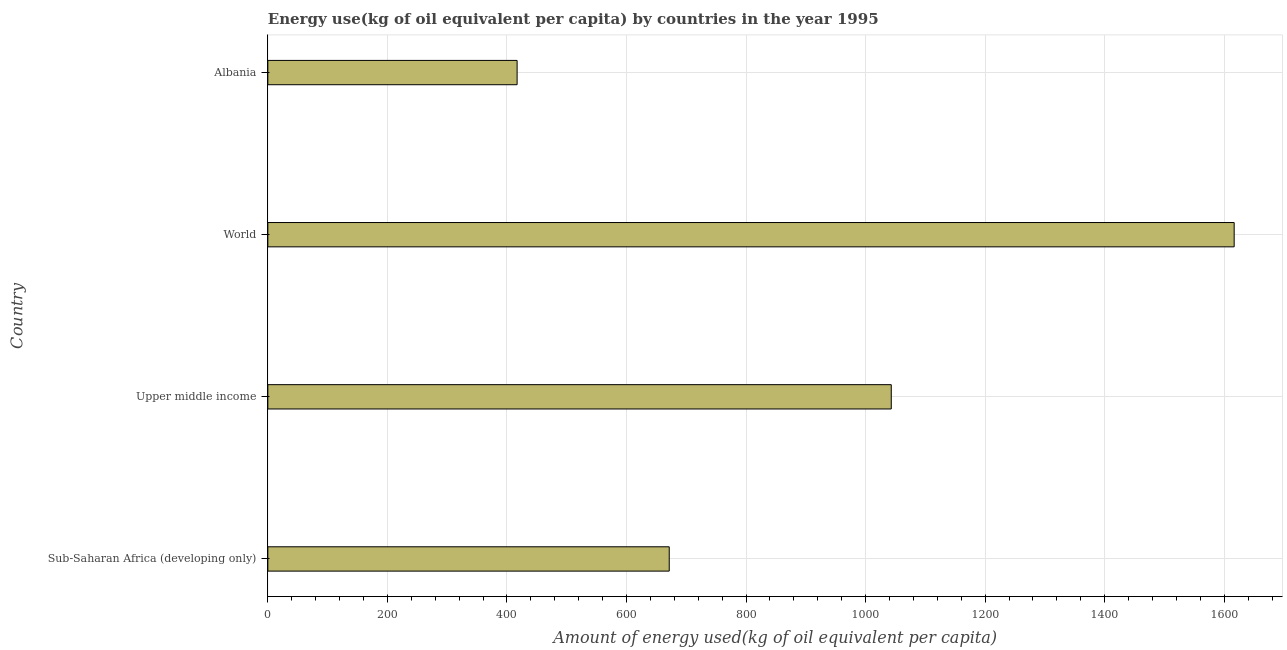What is the title of the graph?
Your answer should be compact. Energy use(kg of oil equivalent per capita) by countries in the year 1995. What is the label or title of the X-axis?
Make the answer very short. Amount of energy used(kg of oil equivalent per capita). What is the amount of energy used in Albania?
Make the answer very short. 417.03. Across all countries, what is the maximum amount of energy used?
Offer a very short reply. 1616.71. Across all countries, what is the minimum amount of energy used?
Keep it short and to the point. 417.03. In which country was the amount of energy used maximum?
Give a very brief answer. World. In which country was the amount of energy used minimum?
Keep it short and to the point. Albania. What is the sum of the amount of energy used?
Make the answer very short. 3748.29. What is the difference between the amount of energy used in Sub-Saharan Africa (developing only) and Upper middle income?
Your answer should be compact. -371.49. What is the average amount of energy used per country?
Ensure brevity in your answer.  937.07. What is the median amount of energy used?
Your answer should be very brief. 857.28. What is the ratio of the amount of energy used in Albania to that in World?
Your response must be concise. 0.26. Is the amount of energy used in Sub-Saharan Africa (developing only) less than that in Upper middle income?
Your response must be concise. Yes. Is the difference between the amount of energy used in Albania and World greater than the difference between any two countries?
Ensure brevity in your answer.  Yes. What is the difference between the highest and the second highest amount of energy used?
Give a very brief answer. 573.69. What is the difference between the highest and the lowest amount of energy used?
Make the answer very short. 1199.67. In how many countries, is the amount of energy used greater than the average amount of energy used taken over all countries?
Offer a terse response. 2. What is the Amount of energy used(kg of oil equivalent per capita) of Sub-Saharan Africa (developing only)?
Make the answer very short. 671.53. What is the Amount of energy used(kg of oil equivalent per capita) of Upper middle income?
Keep it short and to the point. 1043.02. What is the Amount of energy used(kg of oil equivalent per capita) in World?
Provide a succinct answer. 1616.71. What is the Amount of energy used(kg of oil equivalent per capita) of Albania?
Ensure brevity in your answer.  417.03. What is the difference between the Amount of energy used(kg of oil equivalent per capita) in Sub-Saharan Africa (developing only) and Upper middle income?
Keep it short and to the point. -371.49. What is the difference between the Amount of energy used(kg of oil equivalent per capita) in Sub-Saharan Africa (developing only) and World?
Your answer should be compact. -945.17. What is the difference between the Amount of energy used(kg of oil equivalent per capita) in Sub-Saharan Africa (developing only) and Albania?
Make the answer very short. 254.5. What is the difference between the Amount of energy used(kg of oil equivalent per capita) in Upper middle income and World?
Provide a succinct answer. -573.69. What is the difference between the Amount of energy used(kg of oil equivalent per capita) in Upper middle income and Albania?
Offer a very short reply. 625.98. What is the difference between the Amount of energy used(kg of oil equivalent per capita) in World and Albania?
Your answer should be compact. 1199.67. What is the ratio of the Amount of energy used(kg of oil equivalent per capita) in Sub-Saharan Africa (developing only) to that in Upper middle income?
Offer a very short reply. 0.64. What is the ratio of the Amount of energy used(kg of oil equivalent per capita) in Sub-Saharan Africa (developing only) to that in World?
Give a very brief answer. 0.41. What is the ratio of the Amount of energy used(kg of oil equivalent per capita) in Sub-Saharan Africa (developing only) to that in Albania?
Your response must be concise. 1.61. What is the ratio of the Amount of energy used(kg of oil equivalent per capita) in Upper middle income to that in World?
Your answer should be very brief. 0.65. What is the ratio of the Amount of energy used(kg of oil equivalent per capita) in Upper middle income to that in Albania?
Make the answer very short. 2.5. What is the ratio of the Amount of energy used(kg of oil equivalent per capita) in World to that in Albania?
Give a very brief answer. 3.88. 